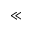<formula> <loc_0><loc_0><loc_500><loc_500>\ll</formula> 